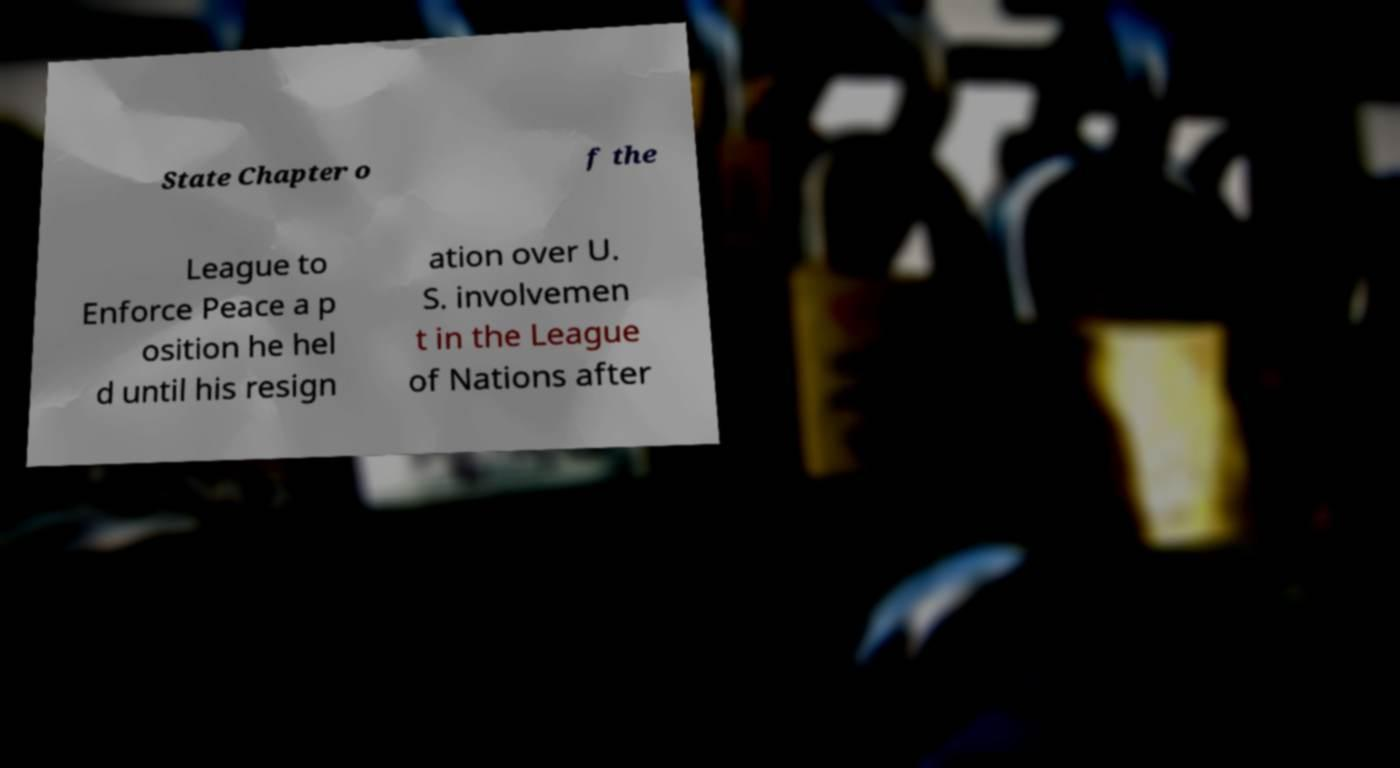There's text embedded in this image that I need extracted. Can you transcribe it verbatim? State Chapter o f the League to Enforce Peace a p osition he hel d until his resign ation over U. S. involvemen t in the League of Nations after 